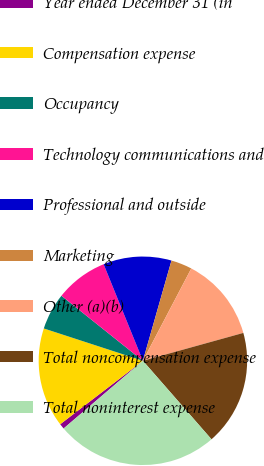Convert chart. <chart><loc_0><loc_0><loc_500><loc_500><pie_chart><fcel>Year ended December 31 (in<fcel>Compensation expense<fcel>Occupancy<fcel>Technology communications and<fcel>Professional and outside<fcel>Marketing<fcel>Other (a)(b)<fcel>Total noncompensation expense<fcel>Total noninterest expense<nl><fcel>0.83%<fcel>15.44%<fcel>5.7%<fcel>8.13%<fcel>10.57%<fcel>3.26%<fcel>13.01%<fcel>17.88%<fcel>25.18%<nl></chart> 